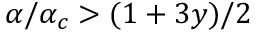<formula> <loc_0><loc_0><loc_500><loc_500>\alpha / \alpha _ { c } > ( 1 + 3 y ) / 2</formula> 